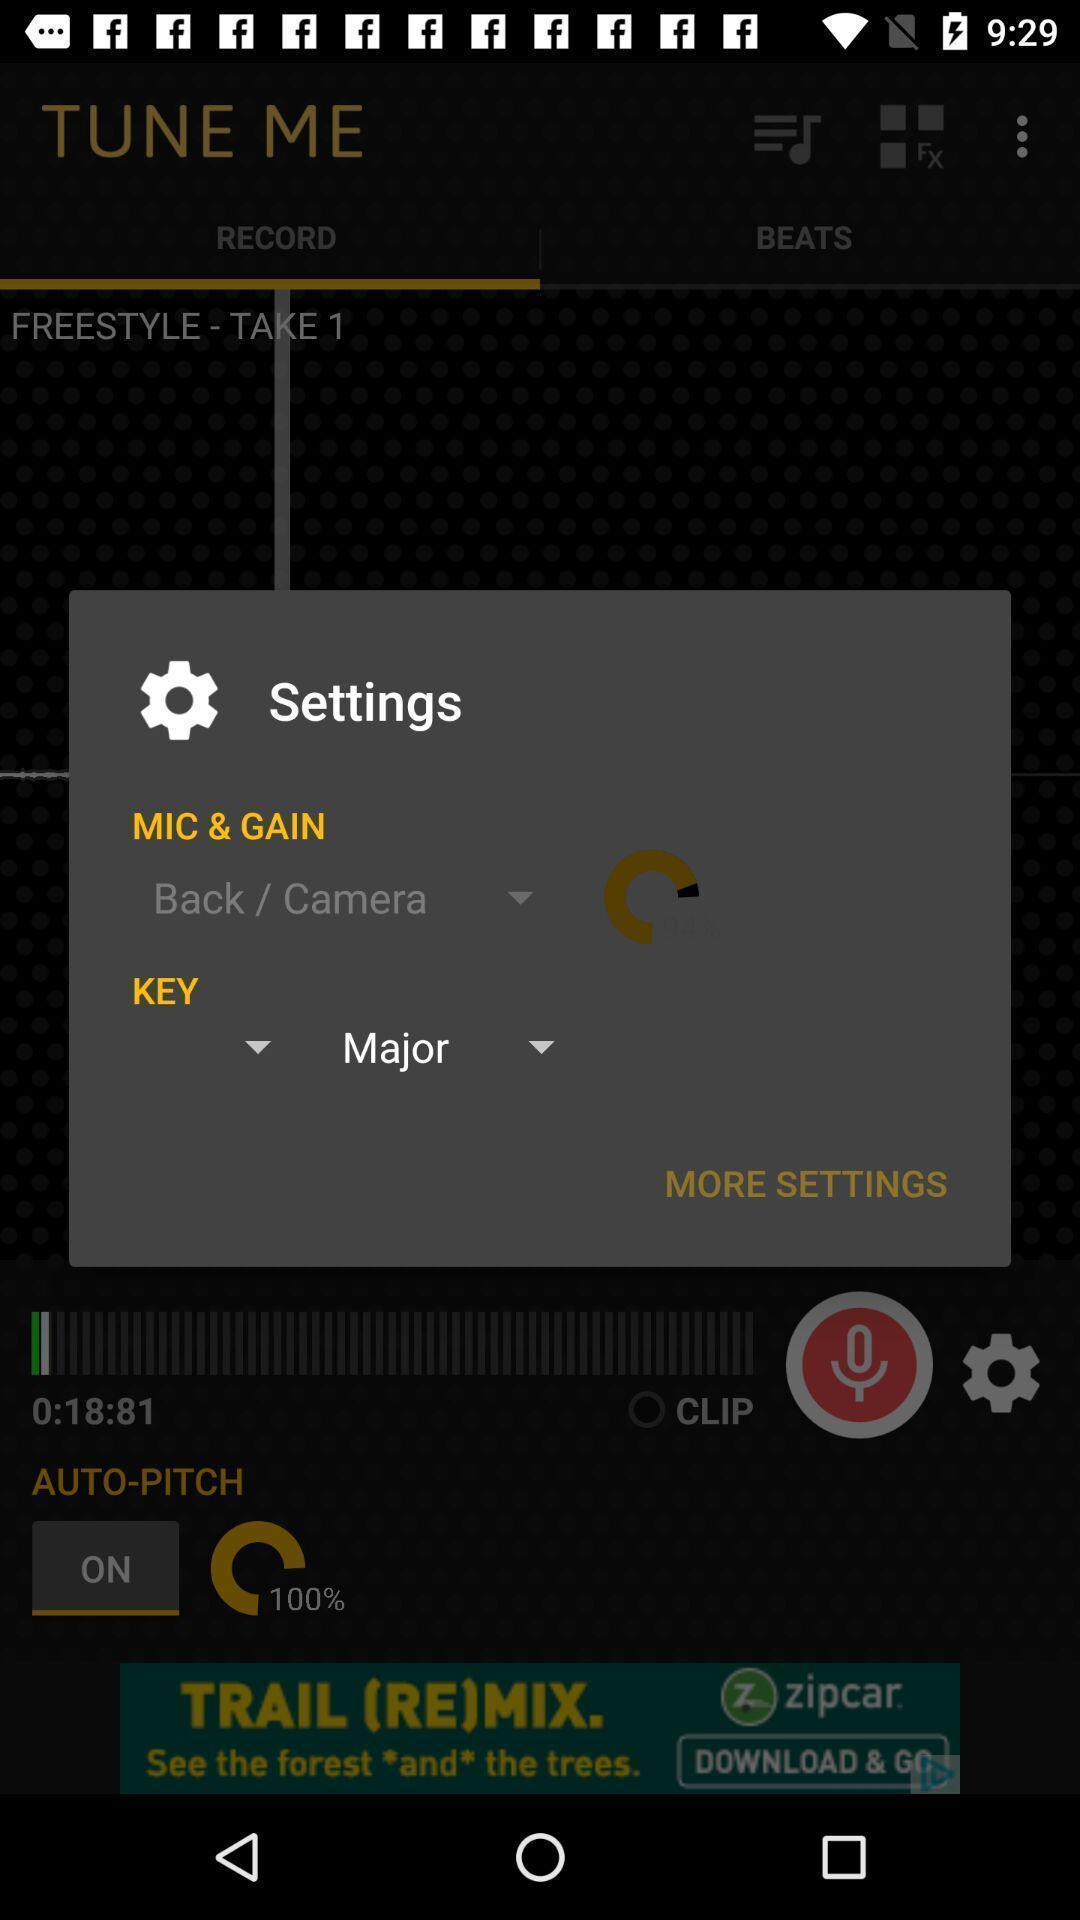Tell me about the visual elements in this screen capture. Pop-up showing the settings options. 